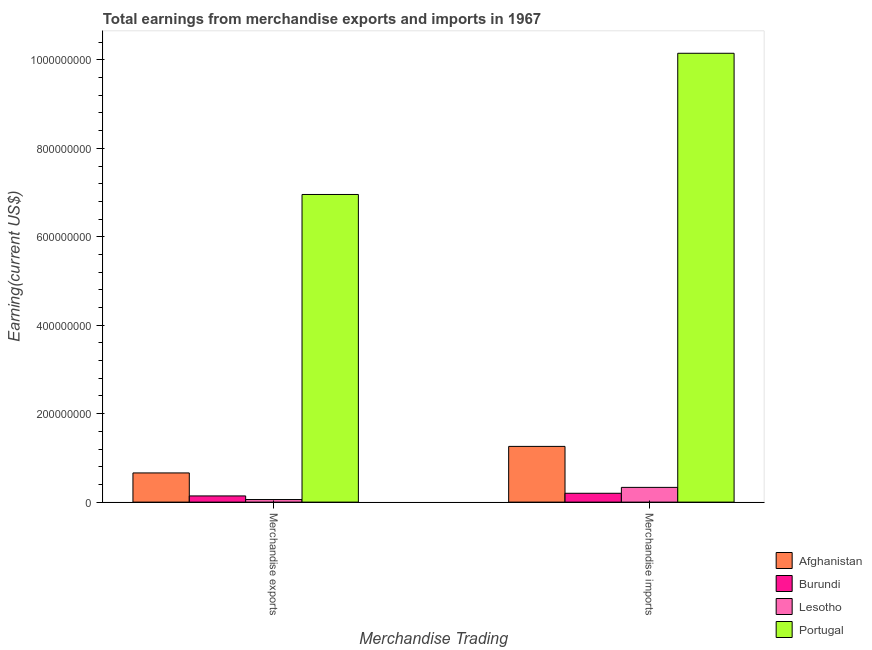How many groups of bars are there?
Your answer should be compact. 2. Are the number of bars per tick equal to the number of legend labels?
Provide a succinct answer. Yes. How many bars are there on the 2nd tick from the left?
Your answer should be compact. 4. What is the label of the 1st group of bars from the left?
Provide a short and direct response. Merchandise exports. What is the earnings from merchandise exports in Afghanistan?
Provide a succinct answer. 6.60e+07. Across all countries, what is the maximum earnings from merchandise exports?
Give a very brief answer. 6.96e+08. Across all countries, what is the minimum earnings from merchandise exports?
Provide a succinct answer. 5.84e+06. In which country was the earnings from merchandise exports minimum?
Your response must be concise. Lesotho. What is the total earnings from merchandise imports in the graph?
Give a very brief answer. 1.19e+09. What is the difference between the earnings from merchandise imports in Portugal and that in Afghanistan?
Give a very brief answer. 8.89e+08. What is the difference between the earnings from merchandise exports in Afghanistan and the earnings from merchandise imports in Portugal?
Make the answer very short. -9.49e+08. What is the average earnings from merchandise imports per country?
Provide a succinct answer. 2.99e+08. What is the difference between the earnings from merchandise imports and earnings from merchandise exports in Portugal?
Offer a very short reply. 3.19e+08. What is the ratio of the earnings from merchandise imports in Portugal to that in Lesotho?
Keep it short and to the point. 30.46. Is the earnings from merchandise imports in Burundi less than that in Lesotho?
Give a very brief answer. Yes. What does the 1st bar from the left in Merchandise imports represents?
Give a very brief answer. Afghanistan. What does the 3rd bar from the right in Merchandise exports represents?
Provide a succinct answer. Burundi. How many countries are there in the graph?
Ensure brevity in your answer.  4. Are the values on the major ticks of Y-axis written in scientific E-notation?
Offer a very short reply. No. How many legend labels are there?
Offer a very short reply. 4. How are the legend labels stacked?
Keep it short and to the point. Vertical. What is the title of the graph?
Offer a terse response. Total earnings from merchandise exports and imports in 1967. Does "Guinea" appear as one of the legend labels in the graph?
Your answer should be very brief. No. What is the label or title of the X-axis?
Offer a terse response. Merchandise Trading. What is the label or title of the Y-axis?
Your response must be concise. Earning(current US$). What is the Earning(current US$) of Afghanistan in Merchandise exports?
Your response must be concise. 6.60e+07. What is the Earning(current US$) of Burundi in Merchandise exports?
Keep it short and to the point. 1.40e+07. What is the Earning(current US$) in Lesotho in Merchandise exports?
Keep it short and to the point. 5.84e+06. What is the Earning(current US$) in Portugal in Merchandise exports?
Make the answer very short. 6.96e+08. What is the Earning(current US$) in Afghanistan in Merchandise imports?
Provide a succinct answer. 1.26e+08. What is the Earning(current US$) of Burundi in Merchandise imports?
Provide a succinct answer. 2.00e+07. What is the Earning(current US$) of Lesotho in Merchandise imports?
Give a very brief answer. 3.33e+07. What is the Earning(current US$) of Portugal in Merchandise imports?
Your answer should be very brief. 1.01e+09. Across all Merchandise Trading, what is the maximum Earning(current US$) of Afghanistan?
Offer a terse response. 1.26e+08. Across all Merchandise Trading, what is the maximum Earning(current US$) in Burundi?
Offer a very short reply. 2.00e+07. Across all Merchandise Trading, what is the maximum Earning(current US$) of Lesotho?
Give a very brief answer. 3.33e+07. Across all Merchandise Trading, what is the maximum Earning(current US$) in Portugal?
Offer a terse response. 1.01e+09. Across all Merchandise Trading, what is the minimum Earning(current US$) of Afghanistan?
Your response must be concise. 6.60e+07. Across all Merchandise Trading, what is the minimum Earning(current US$) in Burundi?
Ensure brevity in your answer.  1.40e+07. Across all Merchandise Trading, what is the minimum Earning(current US$) in Lesotho?
Your answer should be very brief. 5.84e+06. Across all Merchandise Trading, what is the minimum Earning(current US$) of Portugal?
Provide a succinct answer. 6.96e+08. What is the total Earning(current US$) of Afghanistan in the graph?
Make the answer very short. 1.92e+08. What is the total Earning(current US$) in Burundi in the graph?
Provide a short and direct response. 3.40e+07. What is the total Earning(current US$) of Lesotho in the graph?
Your response must be concise. 3.92e+07. What is the total Earning(current US$) of Portugal in the graph?
Keep it short and to the point. 1.71e+09. What is the difference between the Earning(current US$) in Afghanistan in Merchandise exports and that in Merchandise imports?
Make the answer very short. -6.00e+07. What is the difference between the Earning(current US$) of Burundi in Merchandise exports and that in Merchandise imports?
Your answer should be compact. -6.00e+06. What is the difference between the Earning(current US$) in Lesotho in Merchandise exports and that in Merchandise imports?
Ensure brevity in your answer.  -2.75e+07. What is the difference between the Earning(current US$) of Portugal in Merchandise exports and that in Merchandise imports?
Give a very brief answer. -3.19e+08. What is the difference between the Earning(current US$) of Afghanistan in Merchandise exports and the Earning(current US$) of Burundi in Merchandise imports?
Provide a short and direct response. 4.60e+07. What is the difference between the Earning(current US$) of Afghanistan in Merchandise exports and the Earning(current US$) of Lesotho in Merchandise imports?
Provide a succinct answer. 3.27e+07. What is the difference between the Earning(current US$) of Afghanistan in Merchandise exports and the Earning(current US$) of Portugal in Merchandise imports?
Your answer should be compact. -9.49e+08. What is the difference between the Earning(current US$) in Burundi in Merchandise exports and the Earning(current US$) in Lesotho in Merchandise imports?
Provide a succinct answer. -1.93e+07. What is the difference between the Earning(current US$) in Burundi in Merchandise exports and the Earning(current US$) in Portugal in Merchandise imports?
Keep it short and to the point. -1.00e+09. What is the difference between the Earning(current US$) in Lesotho in Merchandise exports and the Earning(current US$) in Portugal in Merchandise imports?
Your response must be concise. -1.01e+09. What is the average Earning(current US$) of Afghanistan per Merchandise Trading?
Your response must be concise. 9.60e+07. What is the average Earning(current US$) of Burundi per Merchandise Trading?
Provide a short and direct response. 1.70e+07. What is the average Earning(current US$) in Lesotho per Merchandise Trading?
Make the answer very short. 1.96e+07. What is the average Earning(current US$) in Portugal per Merchandise Trading?
Give a very brief answer. 8.55e+08. What is the difference between the Earning(current US$) in Afghanistan and Earning(current US$) in Burundi in Merchandise exports?
Provide a short and direct response. 5.20e+07. What is the difference between the Earning(current US$) in Afghanistan and Earning(current US$) in Lesotho in Merchandise exports?
Offer a very short reply. 6.02e+07. What is the difference between the Earning(current US$) of Afghanistan and Earning(current US$) of Portugal in Merchandise exports?
Your answer should be very brief. -6.30e+08. What is the difference between the Earning(current US$) in Burundi and Earning(current US$) in Lesotho in Merchandise exports?
Provide a short and direct response. 8.16e+06. What is the difference between the Earning(current US$) of Burundi and Earning(current US$) of Portugal in Merchandise exports?
Your response must be concise. -6.82e+08. What is the difference between the Earning(current US$) in Lesotho and Earning(current US$) in Portugal in Merchandise exports?
Your answer should be compact. -6.90e+08. What is the difference between the Earning(current US$) of Afghanistan and Earning(current US$) of Burundi in Merchandise imports?
Offer a very short reply. 1.06e+08. What is the difference between the Earning(current US$) in Afghanistan and Earning(current US$) in Lesotho in Merchandise imports?
Your answer should be very brief. 9.27e+07. What is the difference between the Earning(current US$) in Afghanistan and Earning(current US$) in Portugal in Merchandise imports?
Ensure brevity in your answer.  -8.89e+08. What is the difference between the Earning(current US$) of Burundi and Earning(current US$) of Lesotho in Merchandise imports?
Provide a succinct answer. -1.33e+07. What is the difference between the Earning(current US$) of Burundi and Earning(current US$) of Portugal in Merchandise imports?
Your answer should be compact. -9.95e+08. What is the difference between the Earning(current US$) of Lesotho and Earning(current US$) of Portugal in Merchandise imports?
Make the answer very short. -9.82e+08. What is the ratio of the Earning(current US$) of Afghanistan in Merchandise exports to that in Merchandise imports?
Your response must be concise. 0.52. What is the ratio of the Earning(current US$) of Burundi in Merchandise exports to that in Merchandise imports?
Your response must be concise. 0.7. What is the ratio of the Earning(current US$) in Lesotho in Merchandise exports to that in Merchandise imports?
Your response must be concise. 0.18. What is the ratio of the Earning(current US$) of Portugal in Merchandise exports to that in Merchandise imports?
Your answer should be very brief. 0.69. What is the difference between the highest and the second highest Earning(current US$) of Afghanistan?
Your answer should be compact. 6.00e+07. What is the difference between the highest and the second highest Earning(current US$) of Burundi?
Offer a very short reply. 6.00e+06. What is the difference between the highest and the second highest Earning(current US$) of Lesotho?
Give a very brief answer. 2.75e+07. What is the difference between the highest and the second highest Earning(current US$) in Portugal?
Provide a short and direct response. 3.19e+08. What is the difference between the highest and the lowest Earning(current US$) in Afghanistan?
Keep it short and to the point. 6.00e+07. What is the difference between the highest and the lowest Earning(current US$) of Burundi?
Provide a succinct answer. 6.00e+06. What is the difference between the highest and the lowest Earning(current US$) in Lesotho?
Ensure brevity in your answer.  2.75e+07. What is the difference between the highest and the lowest Earning(current US$) in Portugal?
Ensure brevity in your answer.  3.19e+08. 